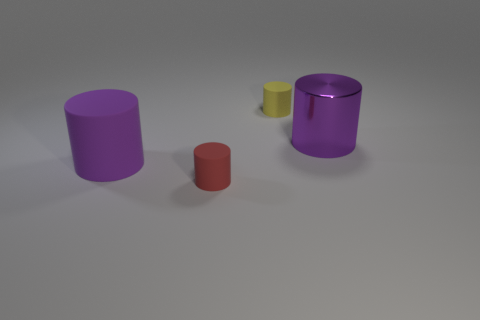Subtract all cyan cylinders. Subtract all brown spheres. How many cylinders are left? 4 Add 2 tiny red cylinders. How many objects exist? 6 Subtract all small green cubes. Subtract all yellow objects. How many objects are left? 3 Add 3 big purple things. How many big purple things are left? 5 Add 2 small red matte cylinders. How many small red matte cylinders exist? 3 Subtract 2 purple cylinders. How many objects are left? 2 